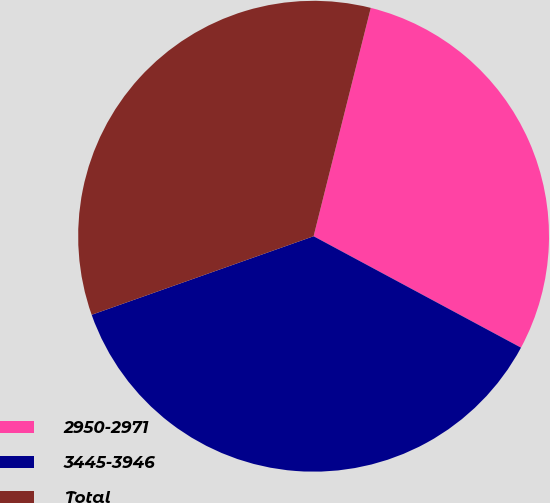Convert chart. <chart><loc_0><loc_0><loc_500><loc_500><pie_chart><fcel>2950-2971<fcel>3445-3946<fcel>Total<nl><fcel>28.94%<fcel>36.74%<fcel>34.32%<nl></chart> 